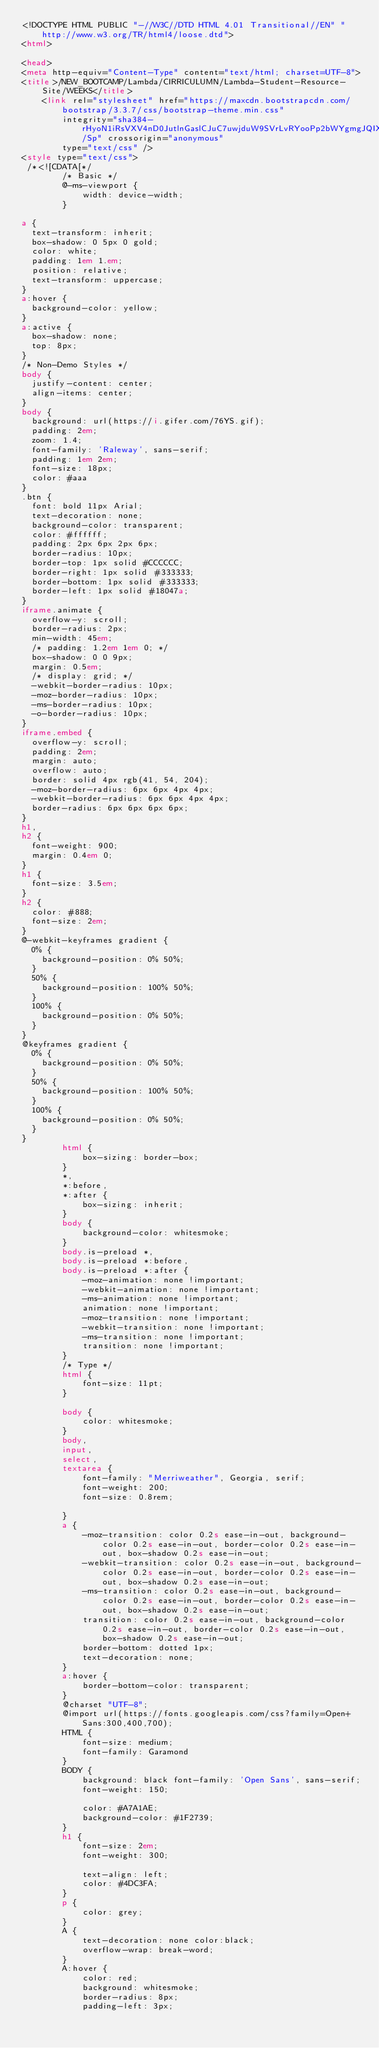<code> <loc_0><loc_0><loc_500><loc_500><_HTML_><!DOCTYPE HTML PUBLIC "-//W3C//DTD HTML 4.01 Transitional//EN" "http://www.w3.org/TR/html4/loose.dtd">
<html>

<head>
<meta http-equiv="Content-Type" content="text/html; charset=UTF-8">
<title>/NEW_BOOTCAMP/Lambda/CIRRICULUMN/Lambda-Student-Resource-Site/WEEKS</title>
    <link rel="stylesheet" href="https://maxcdn.bootstrapcdn.com/bootstrap/3.3.7/css/bootstrap-theme.min.css"
        integrity="sha384-rHyoN1iRsVXV4nD0JutlnGaslCJuC7uwjduW9SVrLvRYooPp2bWYgmgJQIXwl/Sp" crossorigin="anonymous"
        type="text/css" />
<style type="text/css">
 /*<![CDATA[*/
        /* Basic */
        @-ms-viewport {
            width: device-width;
        }
  
a {
  text-transform: inherit;
  box-shadow: 0 5px 0 gold;
  color: white;
  padding: 1em 1.em;
  position: relative;
  text-transform: uppercase;
}
a:hover {
  background-color: yellow;
}
a:active {
  box-shadow: none;
  top: 8px;
}
/* Non-Demo Styles */
body {
  justify-content: center;
  align-items: center;
}
body {
  background: url(https://i.gifer.com/76YS.gif);
  padding: 2em;
  zoom: 1.4;
  font-family: 'Raleway', sans-serif;
  padding: 1em 2em;
  font-size: 18px;
  color: #aaa
}
.btn {
  font: bold 11px Arial;
  text-decoration: none;
  background-color: transparent;
  color: #ffffff;
  padding: 2px 6px 2px 6px;
  border-radius: 10px;
  border-top: 1px solid #CCCCCC;
  border-right: 1px solid #333333;
  border-bottom: 1px solid #333333;
  border-left: 1px solid #18047a;
}
iframe.animate {
  overflow-y: scroll;
  border-radius: 2px;
  min-width: 45em;
  /* padding: 1.2em 1em 0; */
  box-shadow: 0 0 9px;
  margin: 0.5em;
  /* display: grid; */
  -webkit-border-radius: 10px;
  -moz-border-radius: 10px;
  -ms-border-radius: 10px;
  -o-border-radius: 10px;
}
iframe.embed {
  overflow-y: scroll;
  padding: 2em;
  margin: auto;
  overflow: auto;
  border: solid 4px rgb(41, 54, 204);
  -moz-border-radius: 6px 6px 4px 4px;
  -webkit-border-radius: 6px 6px 4px 4px;
  border-radius: 6px 6px 6px 6px;
}
h1,
h2 {
  font-weight: 900;
  margin: 0.4em 0;
}
h1 {
  font-size: 3.5em;
}
h2 {
  color: #888;
  font-size: 2em;
}
@-webkit-keyframes gradient {
  0% {
    background-position: 0% 50%;
  }
  50% {
    background-position: 100% 50%;
  }
  100% {
    background-position: 0% 50%;
  }
}
@keyframes gradient {
  0% {
    background-position: 0% 50%;
  }
  50% {
    background-position: 100% 50%;
  }
  100% {
    background-position: 0% 50%;
  }
}
        html {
            box-sizing: border-box;
        }
        *,
        *:before,
        *:after {
            box-sizing: inherit;
        }
        body {
            background-color: whitesmoke;
        }
        body.is-preload *,
        body.is-preload *:before,
        body.is-preload *:after {
            -moz-animation: none !important;
            -webkit-animation: none !important;
            -ms-animation: none !important;
            animation: none !important;
            -moz-transition: none !important;
            -webkit-transition: none !important;
            -ms-transition: none !important;
            transition: none !important;
        }
        /* Type */
        html {
            font-size: 11pt;
        }
       
        body {
            color: whitesmoke;
        }
        body,
        input,
        select,
        textarea {
            font-family: "Merriweather", Georgia, serif;
            font-weight: 200;
            font-size: 0.8rem;
          
        }
        a {
            -moz-transition: color 0.2s ease-in-out, background-color 0.2s ease-in-out, border-color 0.2s ease-in-out, box-shadow 0.2s ease-in-out;
            -webkit-transition: color 0.2s ease-in-out, background-color 0.2s ease-in-out, border-color 0.2s ease-in-out, box-shadow 0.2s ease-in-out;
            -ms-transition: color 0.2s ease-in-out, background-color 0.2s ease-in-out, border-color 0.2s ease-in-out, box-shadow 0.2s ease-in-out;
            transition: color 0.2s ease-in-out, background-color 0.2s ease-in-out, border-color 0.2s ease-in-out, box-shadow 0.2s ease-in-out;
            border-bottom: dotted 1px;
            text-decoration: none;
        }
        a:hover {
            border-bottom-color: transparent;
        }
        @charset "UTF-8";
        @import url(https://fonts.googleapis.com/css?family=Open+Sans:300,400,700);
        HTML {
            font-size: medium;
            font-family: Garamond
        }
        BODY {
            background: black font-family: 'Open Sans', sans-serif;
            font-weight: 150;
         
            color: #A7A1AE;
            background-color: #1F2739;
        }
        h1 {
            font-size: 2em;
            font-weight: 300;
         
            text-align: left;
            color: #4DC3FA;
        }
        p {
            color: grey;
        }
        A {
            text-decoration: none color:black;
            overflow-wrap: break-word;
        }
        A:hover {
            color: red;
            background: whitesmoke;
            border-radius: 8px;
            padding-left: 3px;</code> 